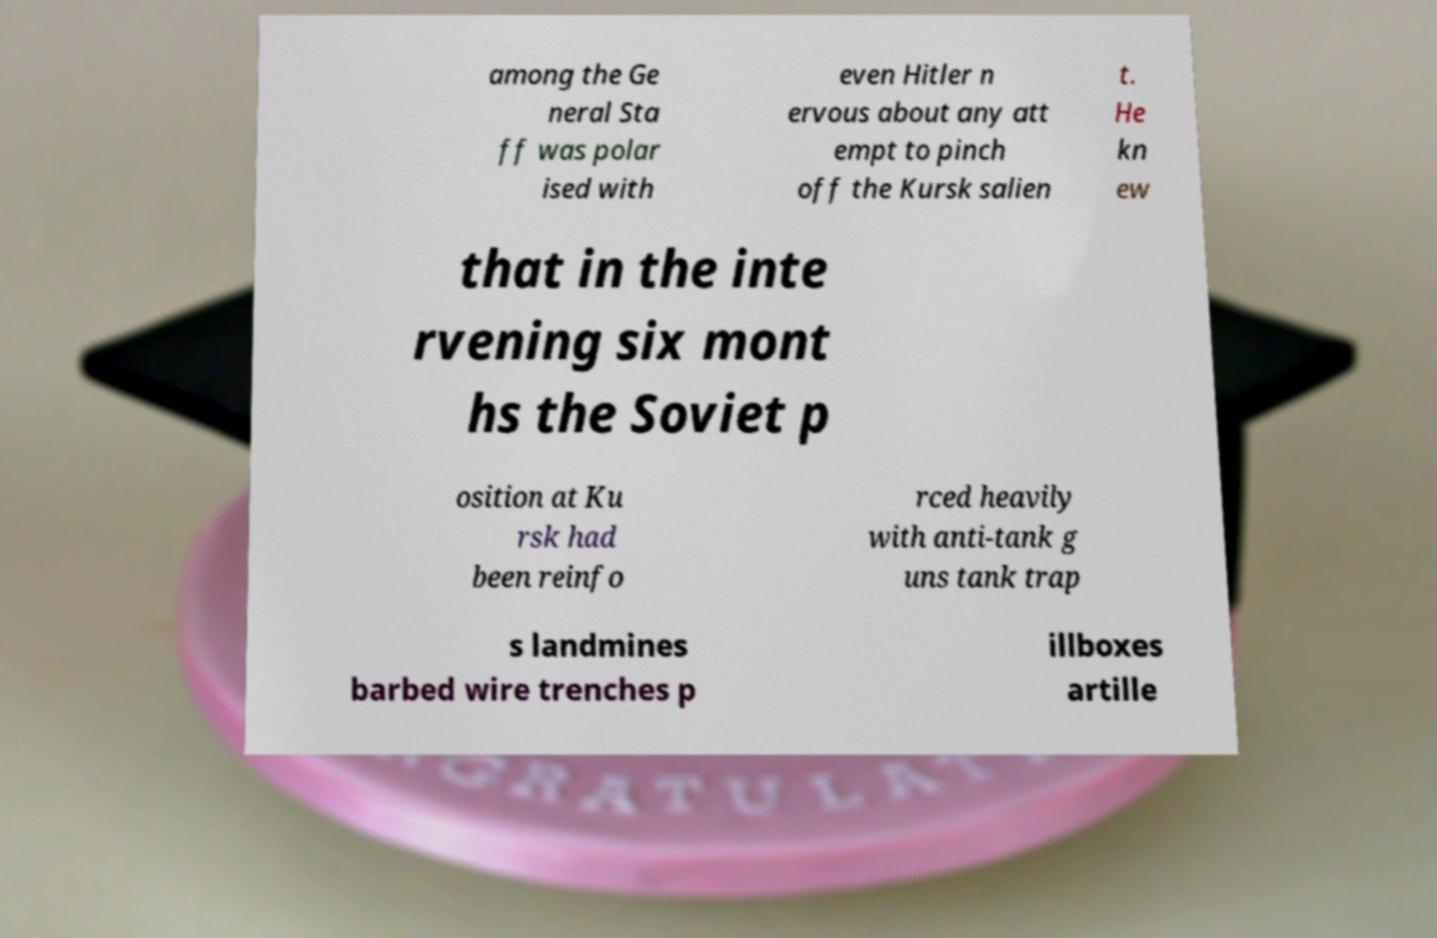Can you read and provide the text displayed in the image?This photo seems to have some interesting text. Can you extract and type it out for me? among the Ge neral Sta ff was polar ised with even Hitler n ervous about any att empt to pinch off the Kursk salien t. He kn ew that in the inte rvening six mont hs the Soviet p osition at Ku rsk had been reinfo rced heavily with anti-tank g uns tank trap s landmines barbed wire trenches p illboxes artille 